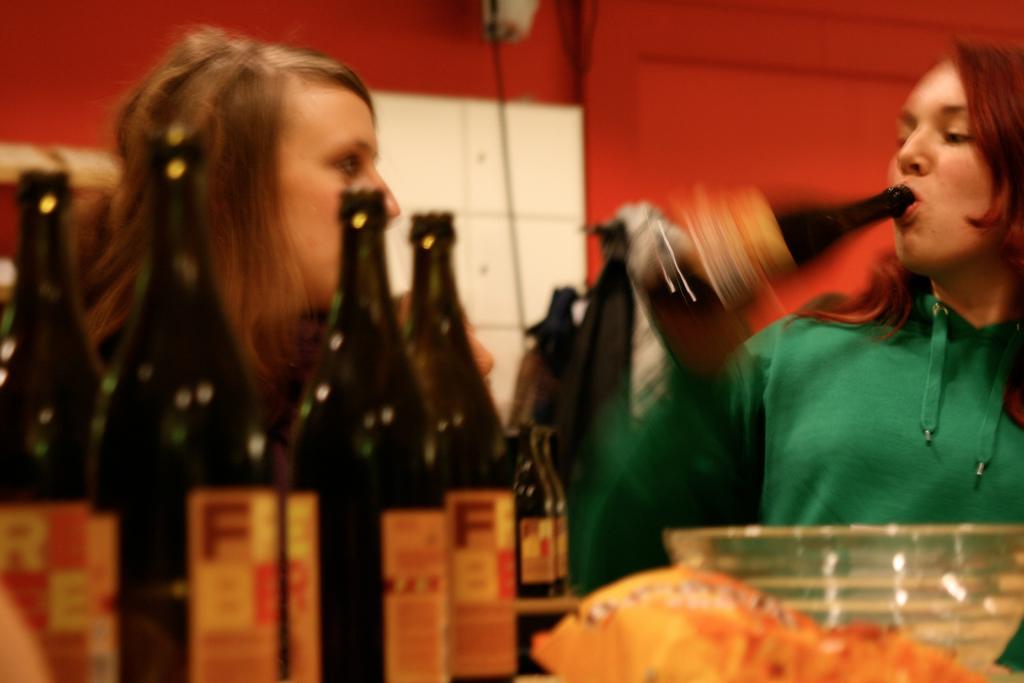Could you give a brief overview of what you see in this image? We can see two persons. This person holding bottle. We can see bottles and bowl. On the background we can see wall. 